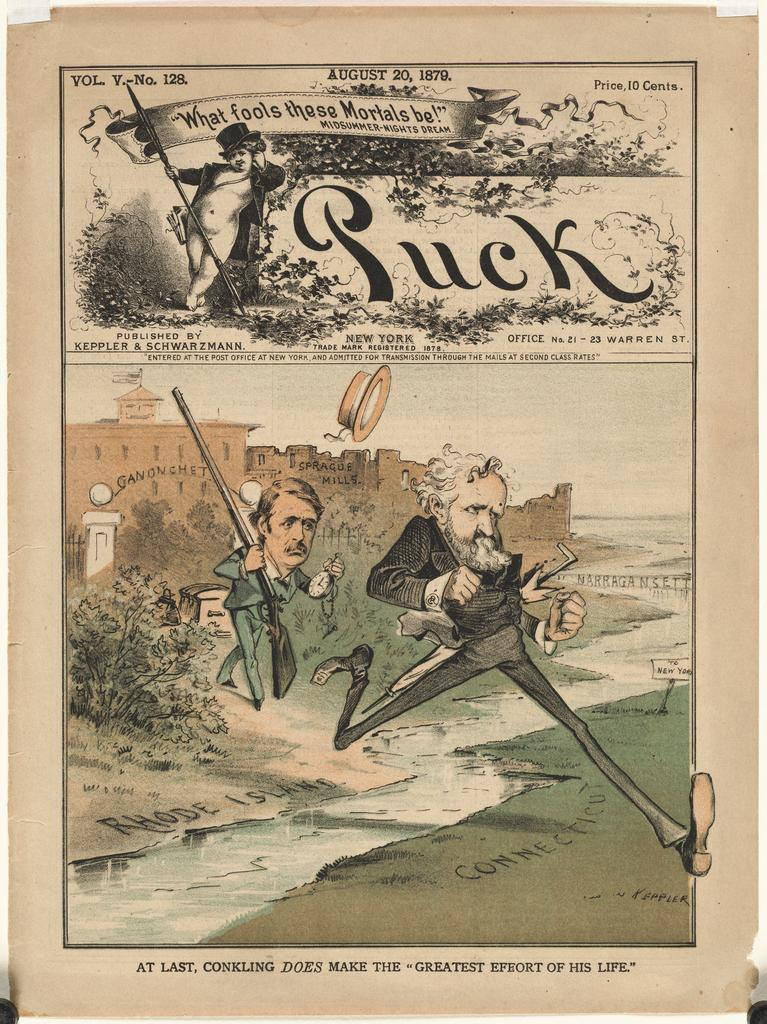<image>
Present a compact description of the photo's key features. Poster showing a man being chased by another man and the words "What fools these mortals be!". 